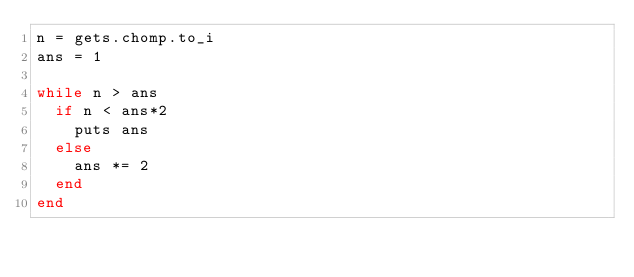<code> <loc_0><loc_0><loc_500><loc_500><_Ruby_>n = gets.chomp.to_i
ans = 1

while n > ans
  if n < ans*2
    puts ans
  else
    ans *= 2
  end
end
</code> 